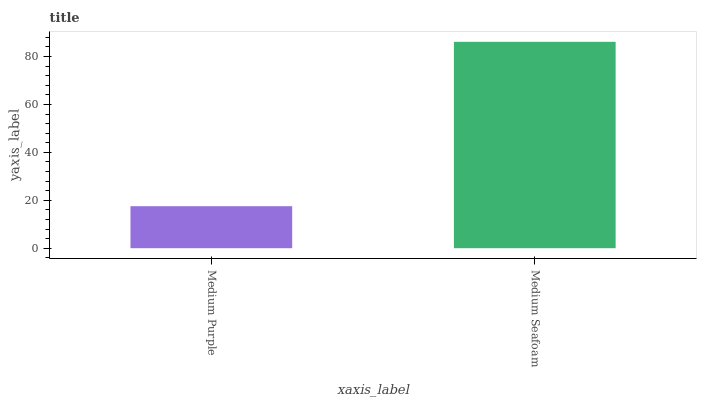Is Medium Purple the minimum?
Answer yes or no. Yes. Is Medium Seafoam the maximum?
Answer yes or no. Yes. Is Medium Seafoam the minimum?
Answer yes or no. No. Is Medium Seafoam greater than Medium Purple?
Answer yes or no. Yes. Is Medium Purple less than Medium Seafoam?
Answer yes or no. Yes. Is Medium Purple greater than Medium Seafoam?
Answer yes or no. No. Is Medium Seafoam less than Medium Purple?
Answer yes or no. No. Is Medium Seafoam the high median?
Answer yes or no. Yes. Is Medium Purple the low median?
Answer yes or no. Yes. Is Medium Purple the high median?
Answer yes or no. No. Is Medium Seafoam the low median?
Answer yes or no. No. 